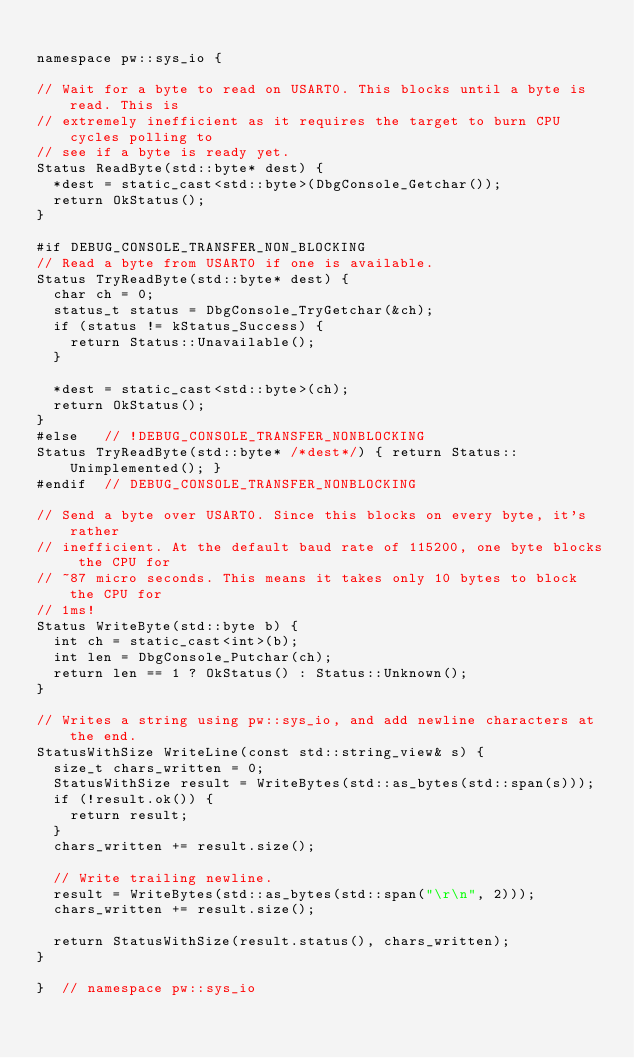<code> <loc_0><loc_0><loc_500><loc_500><_C++_>
namespace pw::sys_io {

// Wait for a byte to read on USART0. This blocks until a byte is read. This is
// extremely inefficient as it requires the target to burn CPU cycles polling to
// see if a byte is ready yet.
Status ReadByte(std::byte* dest) {
  *dest = static_cast<std::byte>(DbgConsole_Getchar());
  return OkStatus();
}

#if DEBUG_CONSOLE_TRANSFER_NON_BLOCKING
// Read a byte from USART0 if one is available.
Status TryReadByte(std::byte* dest) {
  char ch = 0;
  status_t status = DbgConsole_TryGetchar(&ch);
  if (status != kStatus_Success) {
    return Status::Unavailable();
  }

  *dest = static_cast<std::byte>(ch);
  return OkStatus();
}
#else   // !DEBUG_CONSOLE_TRANSFER_NONBLOCKING
Status TryReadByte(std::byte* /*dest*/) { return Status::Unimplemented(); }
#endif  // DEBUG_CONSOLE_TRANSFER_NONBLOCKING

// Send a byte over USART0. Since this blocks on every byte, it's rather
// inefficient. At the default baud rate of 115200, one byte blocks the CPU for
// ~87 micro seconds. This means it takes only 10 bytes to block the CPU for
// 1ms!
Status WriteByte(std::byte b) {
  int ch = static_cast<int>(b);
  int len = DbgConsole_Putchar(ch);
  return len == 1 ? OkStatus() : Status::Unknown();
}

// Writes a string using pw::sys_io, and add newline characters at the end.
StatusWithSize WriteLine(const std::string_view& s) {
  size_t chars_written = 0;
  StatusWithSize result = WriteBytes(std::as_bytes(std::span(s)));
  if (!result.ok()) {
    return result;
  }
  chars_written += result.size();

  // Write trailing newline.
  result = WriteBytes(std::as_bytes(std::span("\r\n", 2)));
  chars_written += result.size();

  return StatusWithSize(result.status(), chars_written);
}

}  // namespace pw::sys_io
</code> 